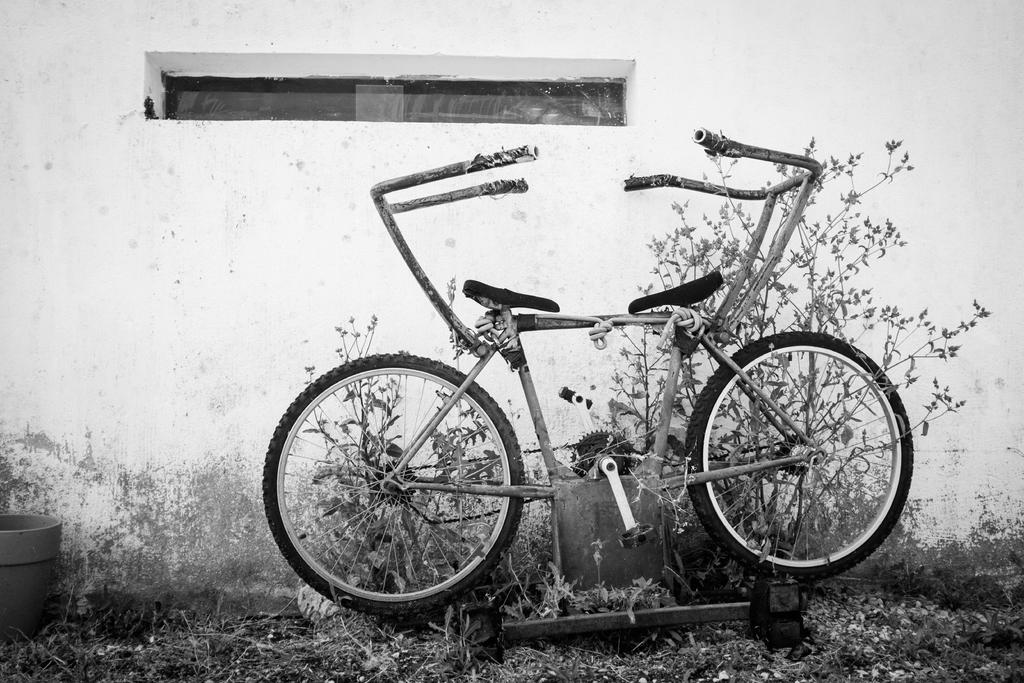What is the color scheme of the image? The image is in black and white. What can be seen in the image besides the color scheme? There is a vehicle and plants visible in the image. Can you describe the plant in the image? There is a pot with leaves in the image. What is visible in the background of the image? There is a wall with a window in the background of the image. What type of grass can be seen growing near the vehicle in the image? There is no grass visible in the image; it is in black and white, and the focus is on the vehicle and plants. Is there a light source visible in the image? There is no light source mentioned or visible in the image, as it is in black and white and focuses on the vehicle, plants, and background. 